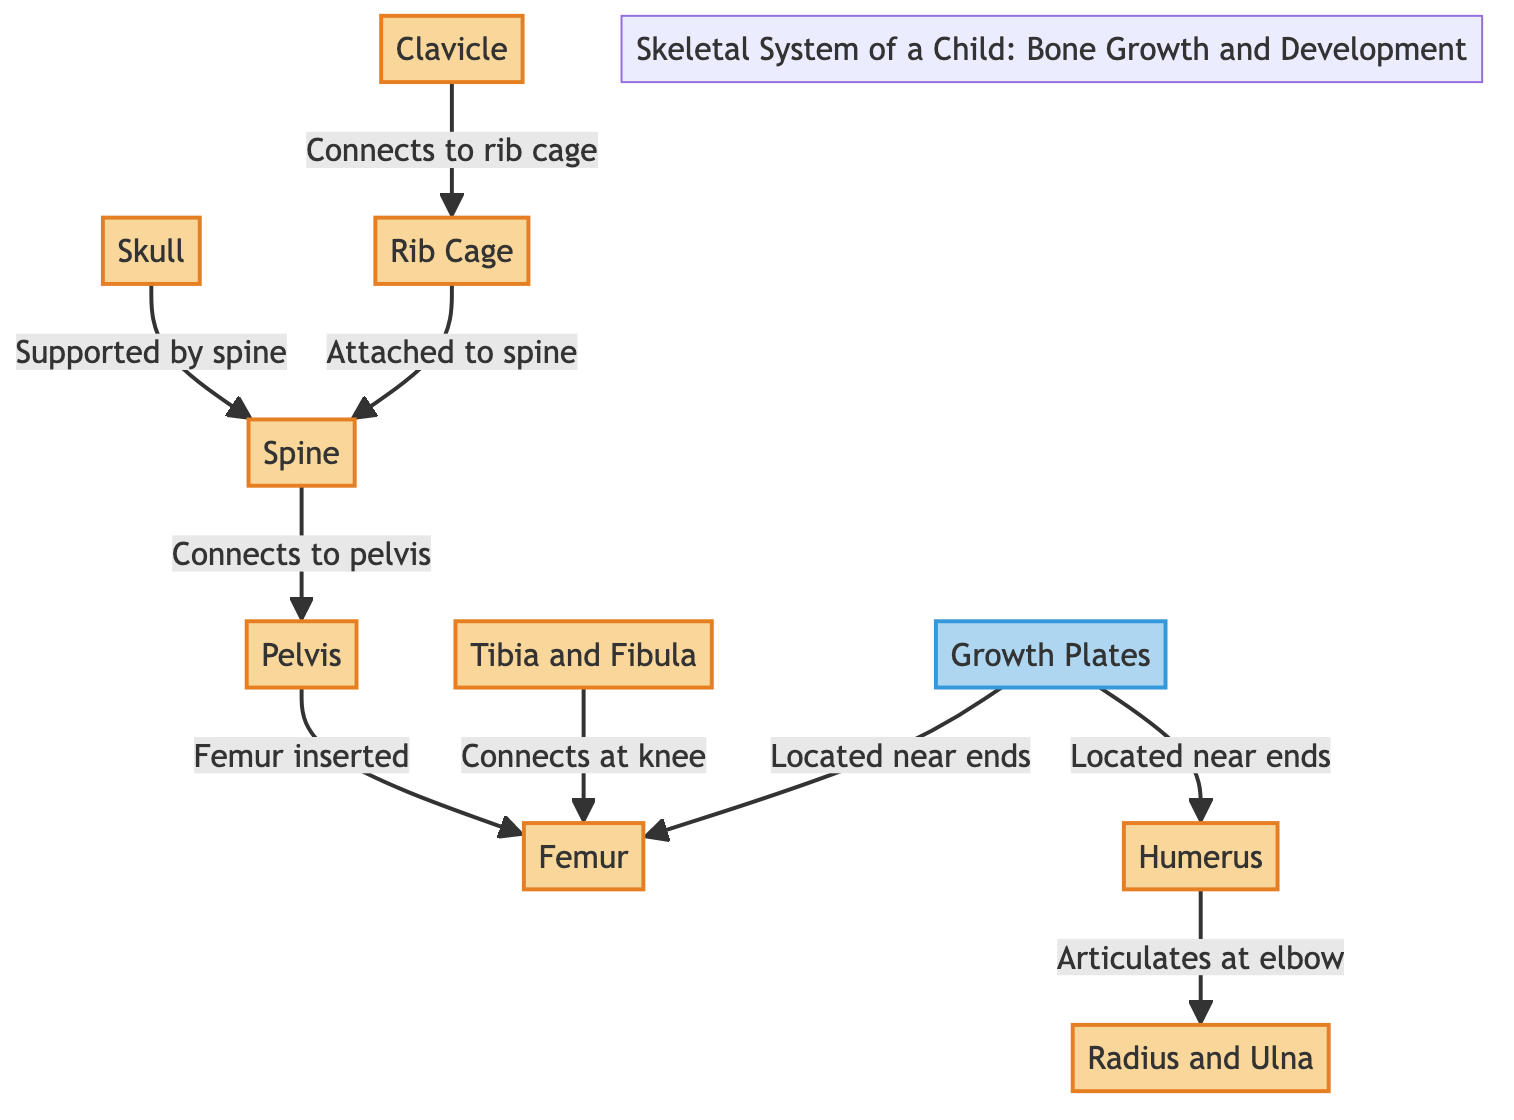What is the first bone mentioned in the diagram? The first bone listed in the diagram is "Skull". There are no preceding mentions or edges connecting to it, making it the starting point of the skeletal system shown.
Answer: Skull Which bone connects to the rib cage? The diagram shows that the "Clavicle" connects to the "Rib Cage". There is a direct edge labeled, indicating their relationship.
Answer: Clavicle How many main bones are directly involved in this skeletal system diagram? By counting the nodes that represent the bones, we find a total of 8 main bones displayed in the diagram: Skull, Clavicle, Rib Cage, Spine, Pelvis, Femur, Humerus, and Radius and Ulna.
Answer: 8 Which bones articulate at the elbow? The diagram specifies that "Humerus" articulates at the "Elbow" with "Radius and Ulna". There is a note indicating that connection.
Answer: Radius and Ulna Where are the growth plates located? The diagram indicates that "Growth Plates" are located near the ends of both the "Humerus" and "Femur". This information is presented through the labeled edges connecting to these two bones.
Answer: Near ends Which bone is inserted into the pelvis? In the diagram, it is stated that the "Femur" is inserted into the "Pelvis", which is shown through the connecting edge between these two bones.
Answer: Femur How does the rib cage connect to the spine? The diagram illustrates that the "Rib Cage" is attached to the "Spine". This relationship is depicted by a direct connection labeled in the diagram.
Answer: Attached Which two bones connect at the knee? The diagram specifies that the "Tibia and Fibula" connect at the "Knee" with the "Femur". It presents a clear relation through the connecting edge depicted.
Answer: Femur 